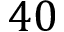<formula> <loc_0><loc_0><loc_500><loc_500>4 0</formula> 